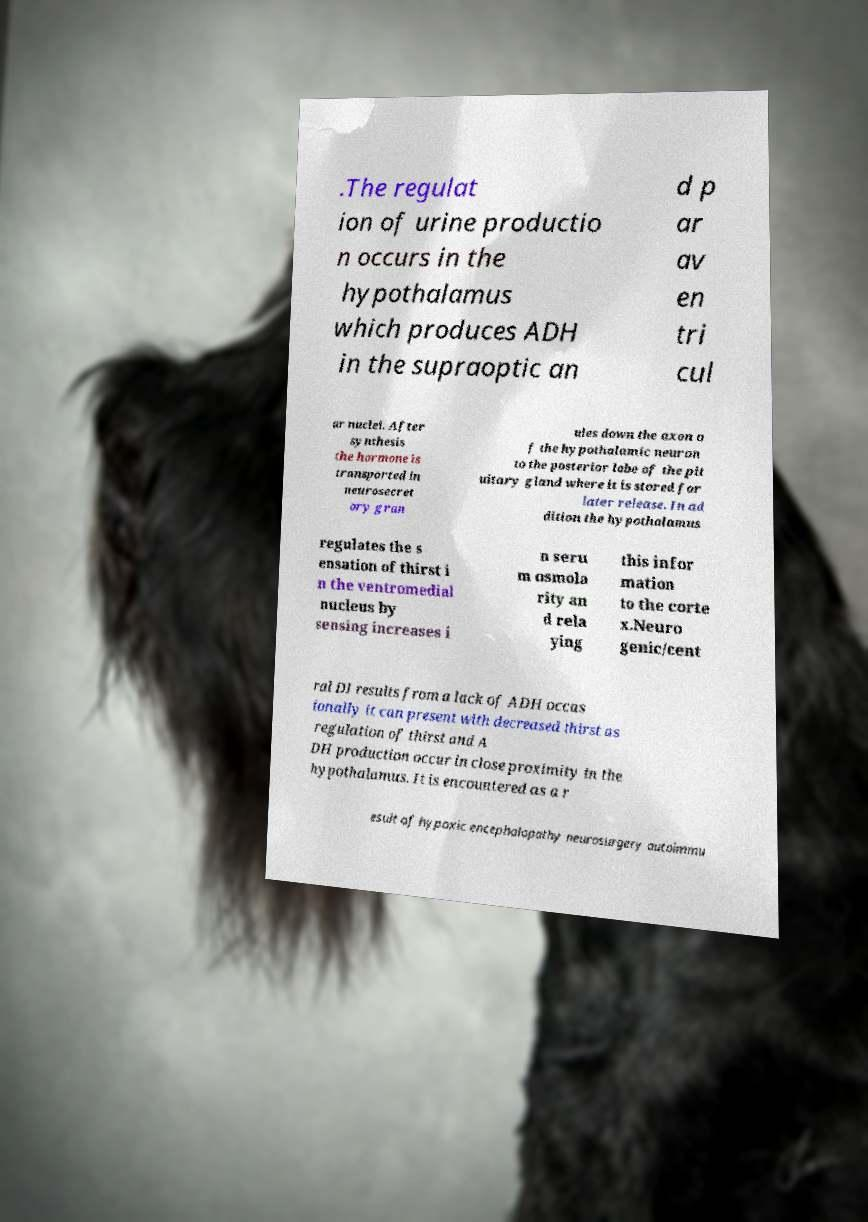Could you extract and type out the text from this image? .The regulat ion of urine productio n occurs in the hypothalamus which produces ADH in the supraoptic an d p ar av en tri cul ar nuclei. After synthesis the hormone is transported in neurosecret ory gran ules down the axon o f the hypothalamic neuron to the posterior lobe of the pit uitary gland where it is stored for later release. In ad dition the hypothalamus regulates the s ensation of thirst i n the ventromedial nucleus by sensing increases i n seru m osmola rity an d rela ying this infor mation to the corte x.Neuro genic/cent ral DI results from a lack of ADH occas ionally it can present with decreased thirst as regulation of thirst and A DH production occur in close proximity in the hypothalamus. It is encountered as a r esult of hypoxic encephalopathy neurosurgery autoimmu 